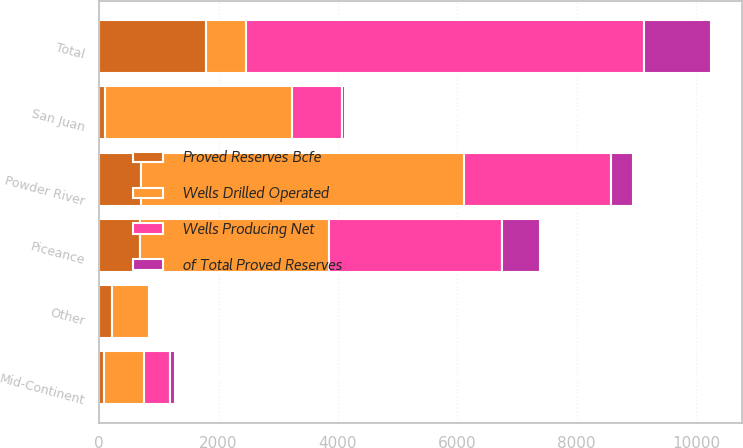Convert chart. <chart><loc_0><loc_0><loc_500><loc_500><stacked_bar_chart><ecel><fcel>Piceance<fcel>San Juan<fcel>Powder River<fcel>Mid-Continent<fcel>Other<fcel>Total<nl><fcel>Proved Reserves Bcfe<fcel>687<fcel>95<fcel>703<fcel>82<fcel>220<fcel>1787<nl><fcel>of Total Proved Reserves<fcel>646<fcel>37<fcel>366<fcel>76<fcel>0<fcel>1125<nl><fcel>Wells Drilled Operated<fcel>3163<fcel>3129<fcel>5407<fcel>672<fcel>611<fcel>672<nl><fcel>Wells Producing Net<fcel>2894<fcel>852<fcel>2465<fcel>434<fcel>21<fcel>6666<nl></chart> 